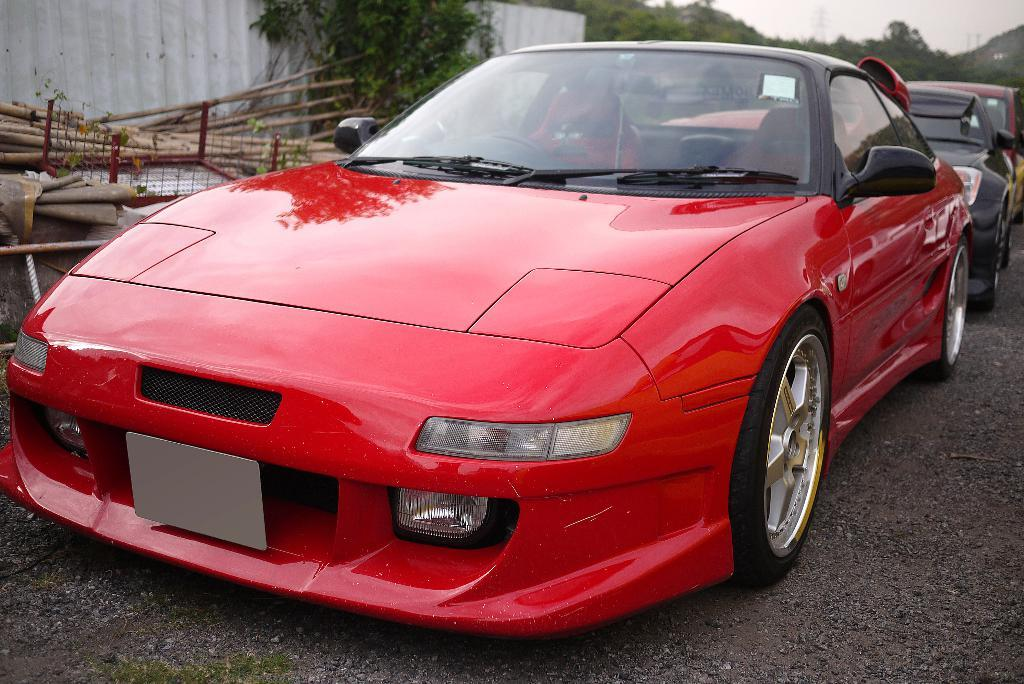What can be seen on the road in the image? There are vehicles on the road in the image. What is visible in the background of the image? There are hills, trees, wooden sticks, and the sky visible in the background of the image. Can you describe the smell of the fairies in the image? There are no fairies present in the image, so it is not possible to describe their smell. Where is the drawer located in the image? There is no drawer present in the image. 